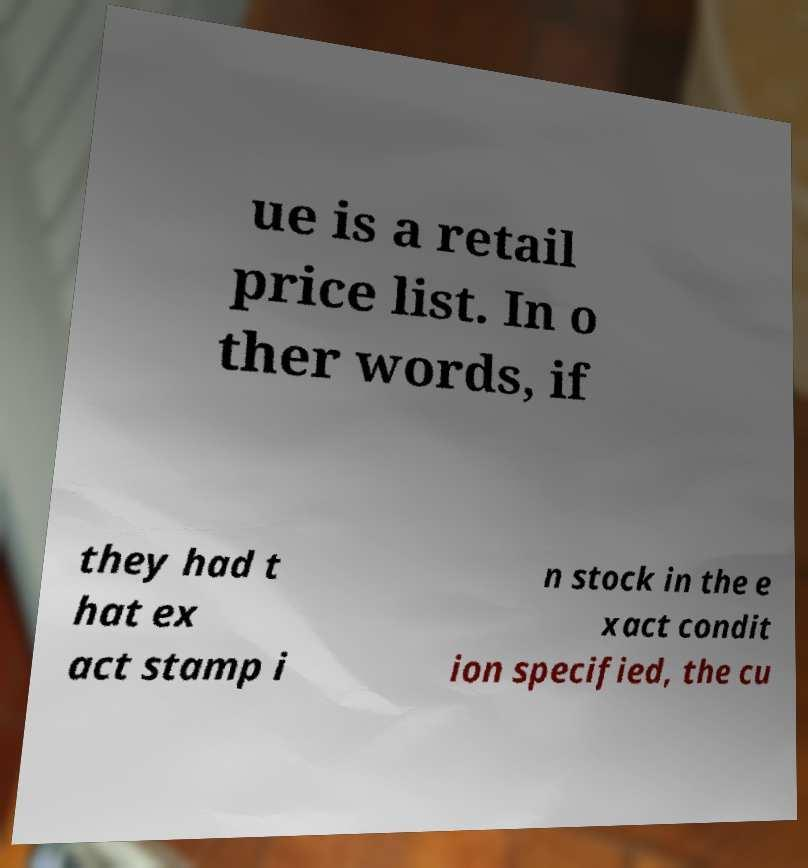Could you assist in decoding the text presented in this image and type it out clearly? ue is a retail price list. In o ther words, if they had t hat ex act stamp i n stock in the e xact condit ion specified, the cu 